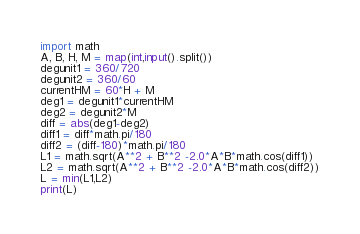Convert code to text. <code><loc_0><loc_0><loc_500><loc_500><_Python_>import math
A, B, H, M = map(int,input().split())
degunit1 = 360/720
degunit2 = 360/60
currentHM = 60*H + M
deg1 = degunit1*currentHM
deg2 = degunit2*M
diff = abs(deg1-deg2)
diff1 = diff*math.pi/180
diff2 = (diff-180)*math.pi/180
L1 = math.sqrt(A**2 + B**2 -2.0*A*B*math.cos(diff1))
L2 = math.sqrt(A**2 + B**2 -2.0*A*B*math.cos(diff2))
L = min(L1,L2)
print(L)</code> 